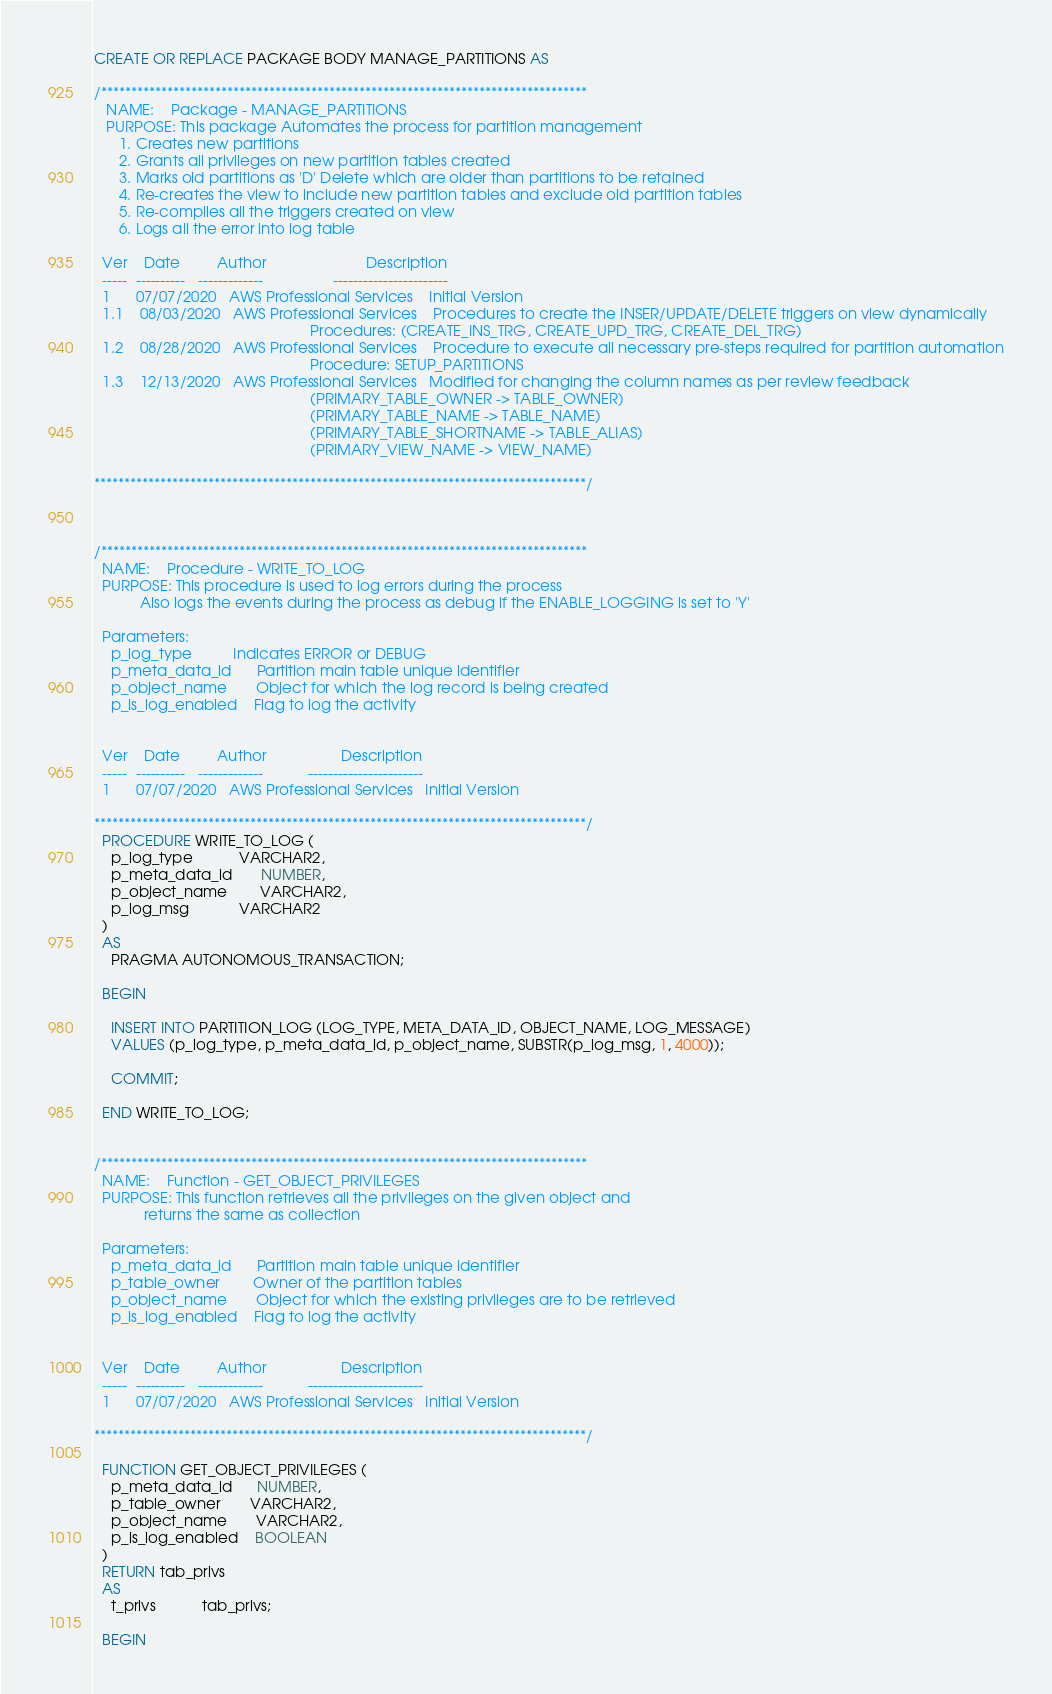<code> <loc_0><loc_0><loc_500><loc_500><_SQL_>CREATE OR REPLACE PACKAGE BODY MANAGE_PARTITIONS AS

/*********************************************************************************
   NAME:    Package - MANAGE_PARTITIONS 
   PURPOSE: This package Automates the process for partition management
      1. Creates new partitions
      2. Grants all privileges on new partition tables created 
      3. Marks old partitions as 'D' Delete which are older than partitions to be retained
      4. Re-creates the view to include new partition tables and exclude old partition tables
      5. Re-compiles all the triggers created on view
      6. Logs all the error into log table
             
  Ver    Date         Author                  		Description
  -----  ----------   -------------           		-----------------------
  1      07/07/2020   AWS Professional Services   	Initial Version
  1.1    08/03/2020   AWS Professional Services   	Procedures to create the INSER/UPDATE/DELETE triggers on view dynamically
													Procedures: (CREATE_INS_TRG, CREATE_UPD_TRG, CREATE_DEL_TRG)
  1.2    08/28/2020   AWS Professional Services   	Procedure to execute all necessary pre-steps required for partition automation
													Procedure: SETUP_PARTITIONS
  1.3    12/13/2020   AWS Professional Services   Modified for changing the column names as per review feedback 
													(PRIMARY_TABLE_OWNER -> TABLE_OWNER)
													(PRIMARY_TABLE_NAME -> TABLE_NAME)
													(PRIMARY_TABLE_SHORTNAME -> TABLE_ALIAS)
													(PRIMARY_VIEW_NAME -> VIEW_NAME)

**********************************************************************************/



/*********************************************************************************
  NAME:    Procedure - WRITE_TO_LOG
  PURPOSE: This procedure is used to log errors during the process
           Also logs the events during the process as debug if the ENABLE_LOGGING is set to 'Y'

  Parameters:
    p_log_type          Indicates ERROR or DEBUG
    p_meta_data_id      Partition main table unique identifier
    p_object_name       Object for which the log record is being created
    p_is_log_enabled    Flag to log the activity

             
  Ver    Date         Author                  Description
  -----  ----------   -------------           -----------------------
  1      07/07/2020   AWS Professional Services   Initial Version

**********************************************************************************/
  PROCEDURE WRITE_TO_LOG (
    p_log_type           VARCHAR2,
    p_meta_data_id       NUMBER,
    p_object_name        VARCHAR2,
    p_log_msg            VARCHAR2
  )
  AS 
    PRAGMA AUTONOMOUS_TRANSACTION;

  BEGIN

    INSERT INTO PARTITION_LOG (LOG_TYPE, META_DATA_ID, OBJECT_NAME, LOG_MESSAGE)
    VALUES (p_log_type, p_meta_data_id, p_object_name, SUBSTR(p_log_msg, 1, 4000));
    
    COMMIT;

  END WRITE_TO_LOG;


/*********************************************************************************
  NAME:    Function - GET_OBJECT_PRIVILEGES
  PURPOSE: This function retrieves all the privileges on the given object and
            returns the same as collection

  Parameters:
    p_meta_data_id      Partition main table unique identifier
    p_table_owner        Owner of the partition tables
    p_object_name       Object for which the existing privileges are to be retrieved
    p_is_log_enabled    Flag to log the activity

             
  Ver    Date         Author                  Description
  -----  ----------   -------------           -----------------------
  1      07/07/2020   AWS Professional Services   Initial Version

**********************************************************************************/

  FUNCTION GET_OBJECT_PRIVILEGES (
    p_meta_data_id      NUMBER,
    p_table_owner       VARCHAR2,
    p_object_name       VARCHAR2,
    p_is_log_enabled    BOOLEAN
  )
  RETURN tab_privs
  AS 
    t_privs           tab_privs;
  
  BEGIN
</code> 